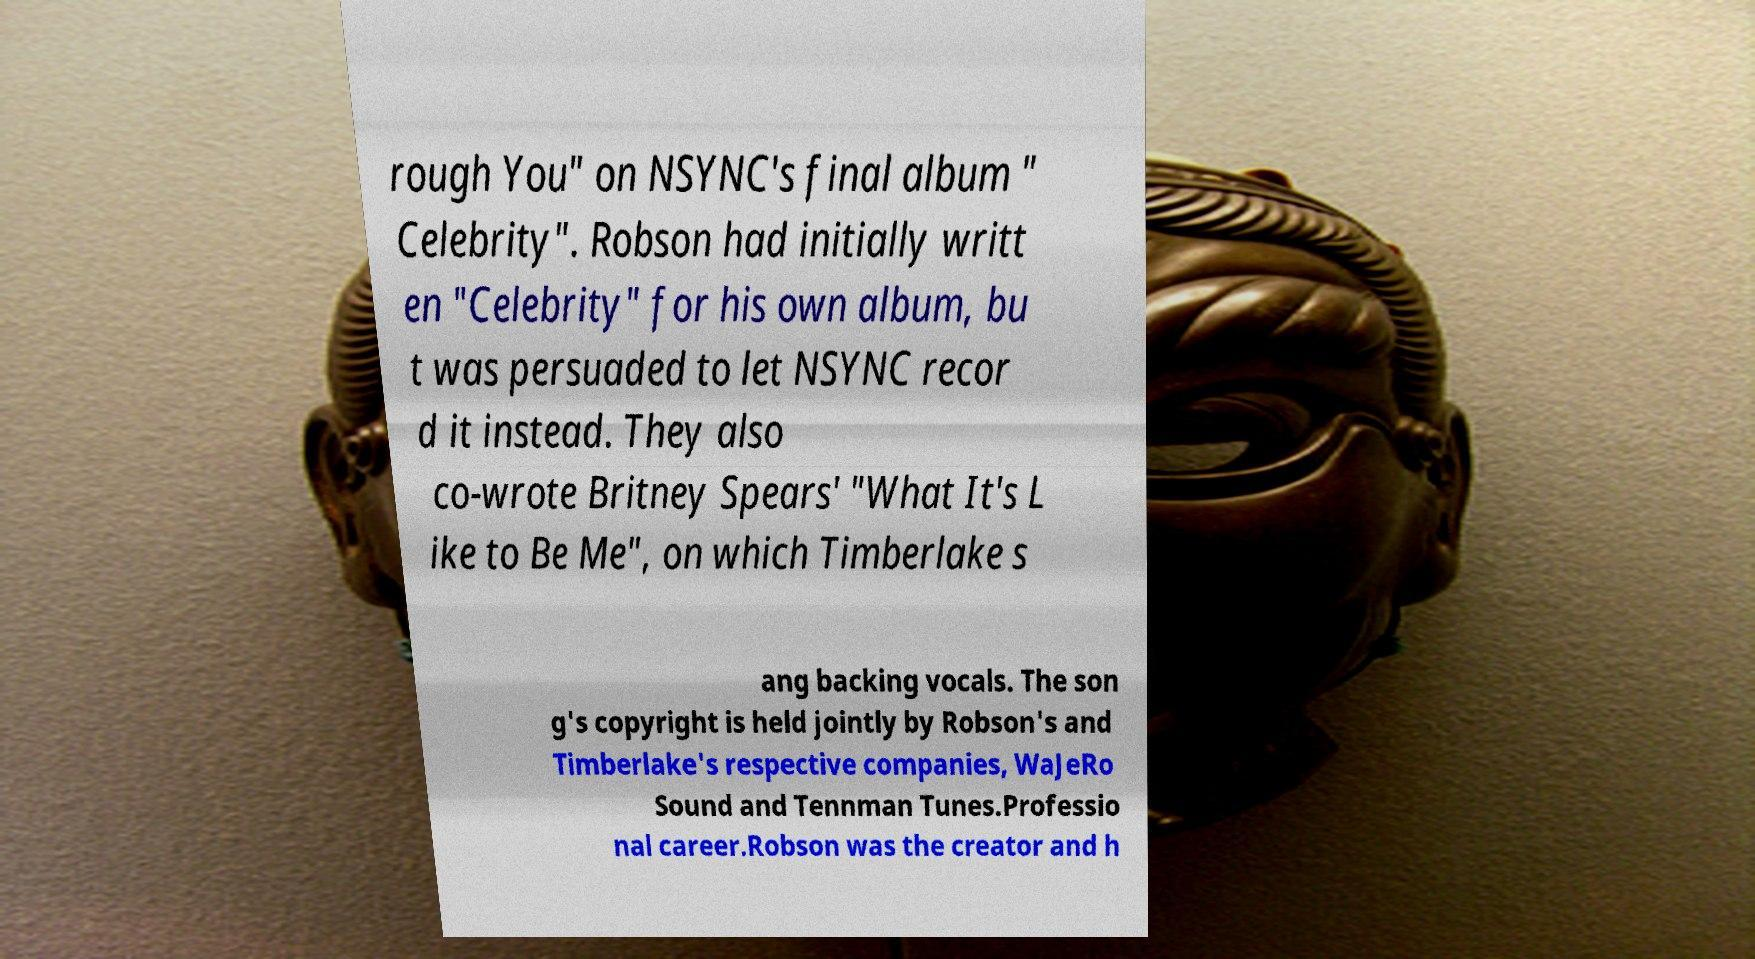Can you read and provide the text displayed in the image?This photo seems to have some interesting text. Can you extract and type it out for me? rough You" on NSYNC's final album " Celebrity". Robson had initially writt en "Celebrity" for his own album, bu t was persuaded to let NSYNC recor d it instead. They also co-wrote Britney Spears' "What It's L ike to Be Me", on which Timberlake s ang backing vocals. The son g's copyright is held jointly by Robson's and Timberlake's respective companies, WaJeRo Sound and Tennman Tunes.Professio nal career.Robson was the creator and h 